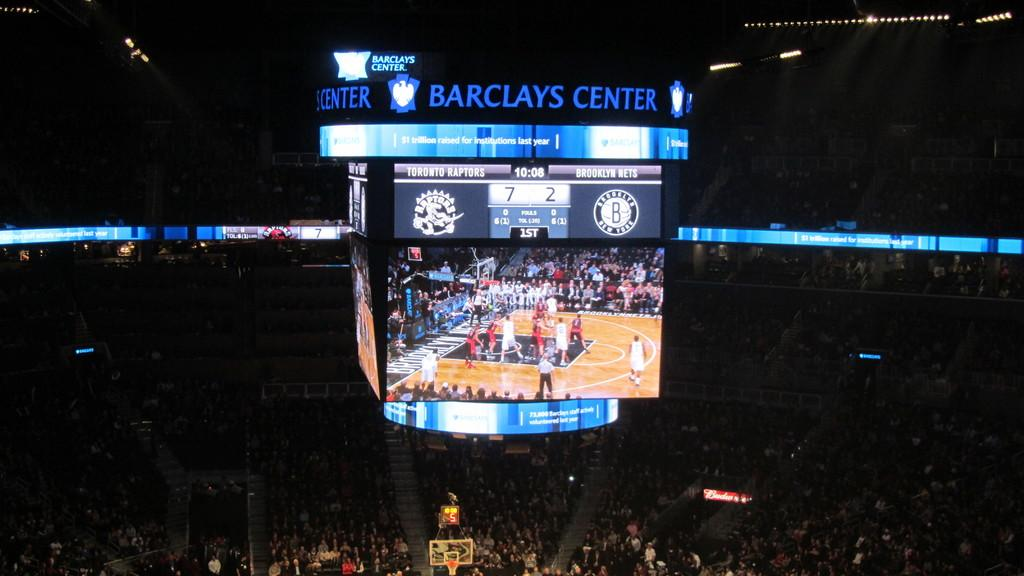<image>
Relay a brief, clear account of the picture shown. a scoreboard with the words Barclay Center on it 